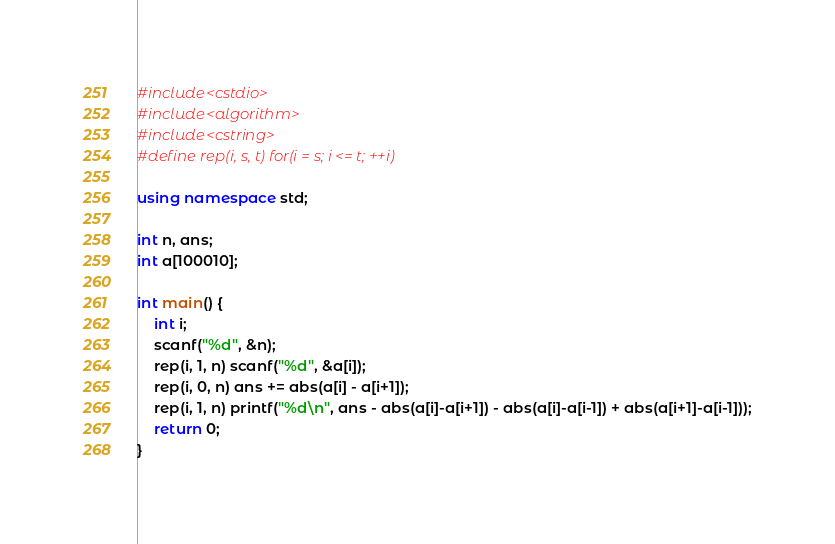<code> <loc_0><loc_0><loc_500><loc_500><_C++_>#include<cstdio>
#include<algorithm>
#include<cstring>
#define rep(i, s, t) for(i = s; i <= t; ++i)

using namespace std;

int n, ans;
int a[100010];

int main() {
	int i;
	scanf("%d", &n);
	rep(i, 1, n) scanf("%d", &a[i]);
	rep(i, 0, n) ans += abs(a[i] - a[i+1]);
	rep(i, 1, n) printf("%d\n", ans - abs(a[i]-a[i+1]) - abs(a[i]-a[i-1]) + abs(a[i+1]-a[i-1]));
	return 0;
}</code> 